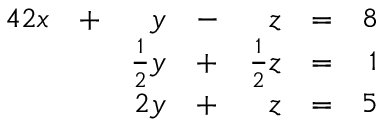Convert formula to latex. <formula><loc_0><loc_0><loc_500><loc_500>{ \begin{array} { r l r l r l r l } { { 4 } 2 x } & { + } & { y } & { - } & { z } & { = } & { 8 } \\ & { { \frac { 1 } { 2 } } y } & { + } & { { \frac { 1 } { 2 } } z } & { = } & { 1 } \\ & { 2 y } & { + } & { z } & { = } & { 5 } \end{array} }</formula> 